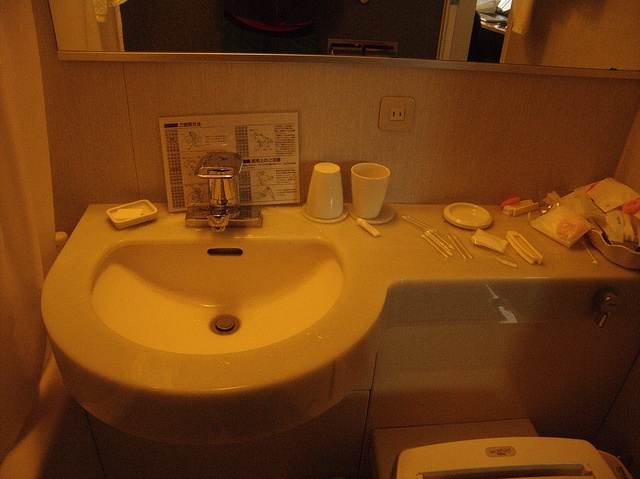Describe the objects in this image and their specific colors. I can see sink in maroon, red, and orange tones, toilet in maroon, brown, and black tones, cup in maroon, olive, orange, and gray tones, and cup in maroon, olive, and orange tones in this image. 